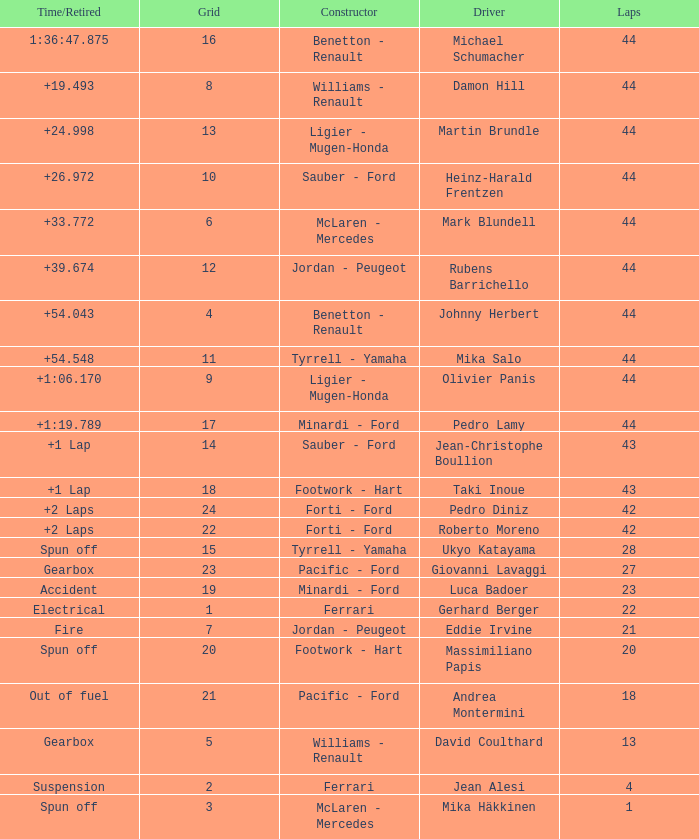What is the high lap total for cards with a grid larger than 21, and a Time/Retired of +2 laps? 42.0. 